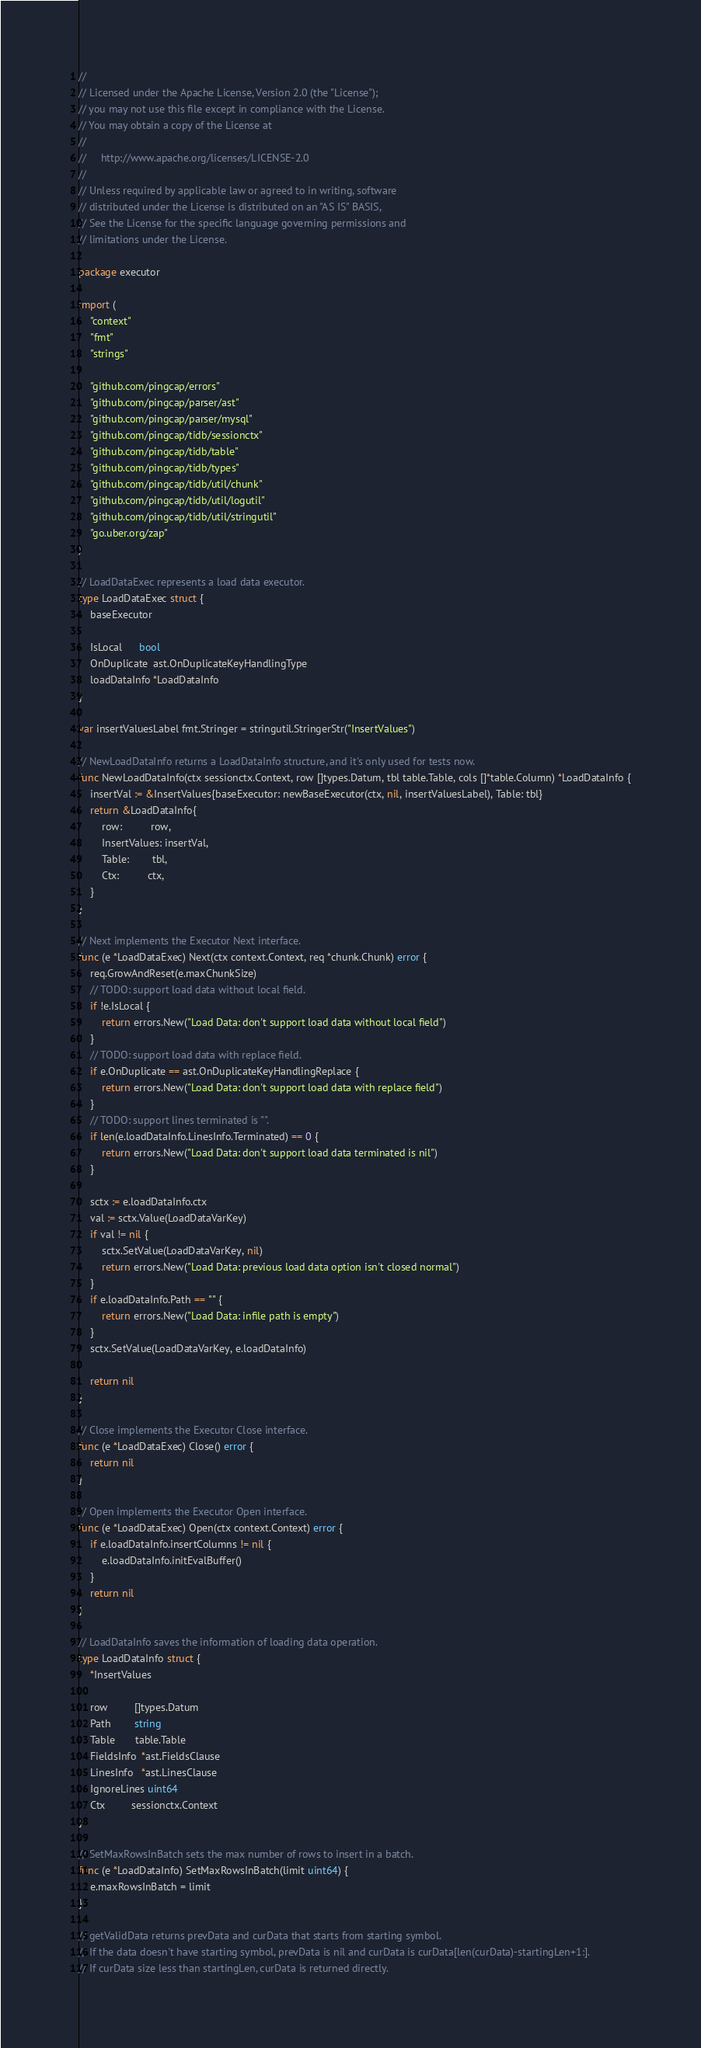Convert code to text. <code><loc_0><loc_0><loc_500><loc_500><_Go_>//
// Licensed under the Apache License, Version 2.0 (the "License");
// you may not use this file except in compliance with the License.
// You may obtain a copy of the License at
//
//     http://www.apache.org/licenses/LICENSE-2.0
//
// Unless required by applicable law or agreed to in writing, software
// distributed under the License is distributed on an "AS IS" BASIS,
// See the License for the specific language governing permissions and
// limitations under the License.

package executor

import (
	"context"
	"fmt"
	"strings"

	"github.com/pingcap/errors"
	"github.com/pingcap/parser/ast"
	"github.com/pingcap/parser/mysql"
	"github.com/pingcap/tidb/sessionctx"
	"github.com/pingcap/tidb/table"
	"github.com/pingcap/tidb/types"
	"github.com/pingcap/tidb/util/chunk"
	"github.com/pingcap/tidb/util/logutil"
	"github.com/pingcap/tidb/util/stringutil"
	"go.uber.org/zap"
)

// LoadDataExec represents a load data executor.
type LoadDataExec struct {
	baseExecutor

	IsLocal      bool
	OnDuplicate  ast.OnDuplicateKeyHandlingType
	loadDataInfo *LoadDataInfo
}

var insertValuesLabel fmt.Stringer = stringutil.StringerStr("InsertValues")

// NewLoadDataInfo returns a LoadDataInfo structure, and it's only used for tests now.
func NewLoadDataInfo(ctx sessionctx.Context, row []types.Datum, tbl table.Table, cols []*table.Column) *LoadDataInfo {
	insertVal := &InsertValues{baseExecutor: newBaseExecutor(ctx, nil, insertValuesLabel), Table: tbl}
	return &LoadDataInfo{
		row:          row,
		InsertValues: insertVal,
		Table:        tbl,
		Ctx:          ctx,
	}
}

// Next implements the Executor Next interface.
func (e *LoadDataExec) Next(ctx context.Context, req *chunk.Chunk) error {
	req.GrowAndReset(e.maxChunkSize)
	// TODO: support load data without local field.
	if !e.IsLocal {
		return errors.New("Load Data: don't support load data without local field")
	}
	// TODO: support load data with replace field.
	if e.OnDuplicate == ast.OnDuplicateKeyHandlingReplace {
		return errors.New("Load Data: don't support load data with replace field")
	}
	// TODO: support lines terminated is "".
	if len(e.loadDataInfo.LinesInfo.Terminated) == 0 {
		return errors.New("Load Data: don't support load data terminated is nil")
	}

	sctx := e.loadDataInfo.ctx
	val := sctx.Value(LoadDataVarKey)
	if val != nil {
		sctx.SetValue(LoadDataVarKey, nil)
		return errors.New("Load Data: previous load data option isn't closed normal")
	}
	if e.loadDataInfo.Path == "" {
		return errors.New("Load Data: infile path is empty")
	}
	sctx.SetValue(LoadDataVarKey, e.loadDataInfo)

	return nil
}

// Close implements the Executor Close interface.
func (e *LoadDataExec) Close() error {
	return nil
}

// Open implements the Executor Open interface.
func (e *LoadDataExec) Open(ctx context.Context) error {
	if e.loadDataInfo.insertColumns != nil {
		e.loadDataInfo.initEvalBuffer()
	}
	return nil
}

// LoadDataInfo saves the information of loading data operation.
type LoadDataInfo struct {
	*InsertValues

	row         []types.Datum
	Path        string
	Table       table.Table
	FieldsInfo  *ast.FieldsClause
	LinesInfo   *ast.LinesClause
	IgnoreLines uint64
	Ctx         sessionctx.Context
}

// SetMaxRowsInBatch sets the max number of rows to insert in a batch.
func (e *LoadDataInfo) SetMaxRowsInBatch(limit uint64) {
	e.maxRowsInBatch = limit
}

// getValidData returns prevData and curData that starts from starting symbol.
// If the data doesn't have starting symbol, prevData is nil and curData is curData[len(curData)-startingLen+1:].
// If curData size less than startingLen, curData is returned directly.</code> 